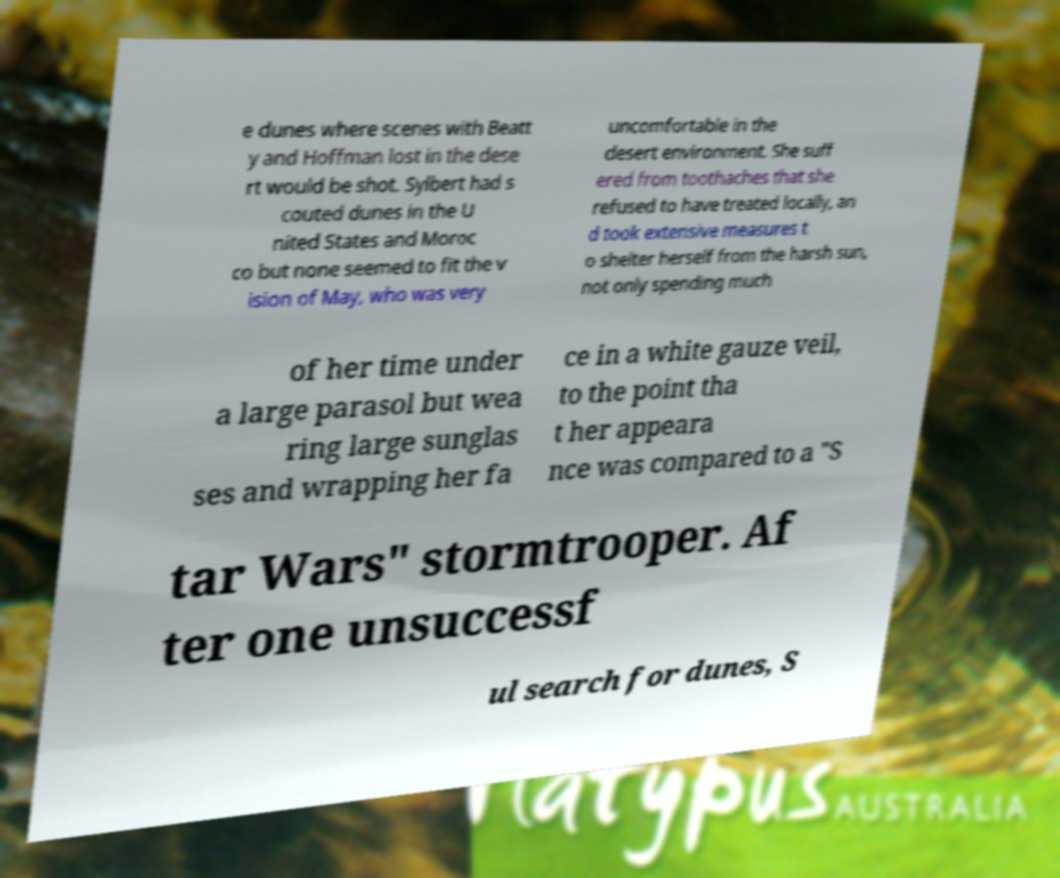Can you accurately transcribe the text from the provided image for me? e dunes where scenes with Beatt y and Hoffman lost in the dese rt would be shot. Sylbert had s couted dunes in the U nited States and Moroc co but none seemed to fit the v ision of May, who was very uncomfortable in the desert environment. She suff ered from toothaches that she refused to have treated locally, an d took extensive measures t o shelter herself from the harsh sun, not only spending much of her time under a large parasol but wea ring large sunglas ses and wrapping her fa ce in a white gauze veil, to the point tha t her appeara nce was compared to a "S tar Wars" stormtrooper. Af ter one unsuccessf ul search for dunes, S 